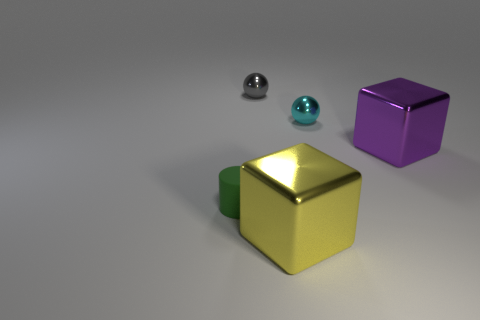Subtract 1 cubes. How many cubes are left? 1 Subtract all purple cylinders. Subtract all green cubes. How many cylinders are left? 1 Subtract all green cylinders. How many purple blocks are left? 1 Add 2 big objects. How many big objects are left? 4 Add 5 large purple things. How many large purple things exist? 6 Add 5 green matte cylinders. How many objects exist? 10 Subtract 1 yellow cubes. How many objects are left? 4 Subtract all cylinders. How many objects are left? 4 Subtract all big yellow objects. Subtract all tiny gray shiny objects. How many objects are left? 3 